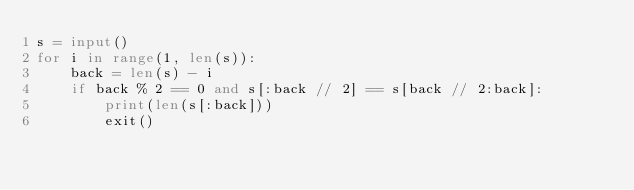Convert code to text. <code><loc_0><loc_0><loc_500><loc_500><_Python_>s = input()
for i in range(1, len(s)):
    back = len(s) - i
    if back % 2 == 0 and s[:back // 2] == s[back // 2:back]:
        print(len(s[:back]))
        exit()</code> 